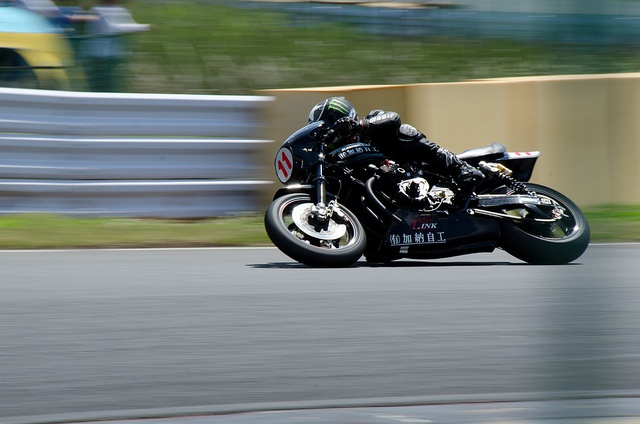Describe the objects in this image and their specific colors. I can see motorcycle in gray, black, white, and darkgray tones, people in gray, black, darkgray, and lightgray tones, and people in gray, teal, black, and darkgray tones in this image. 